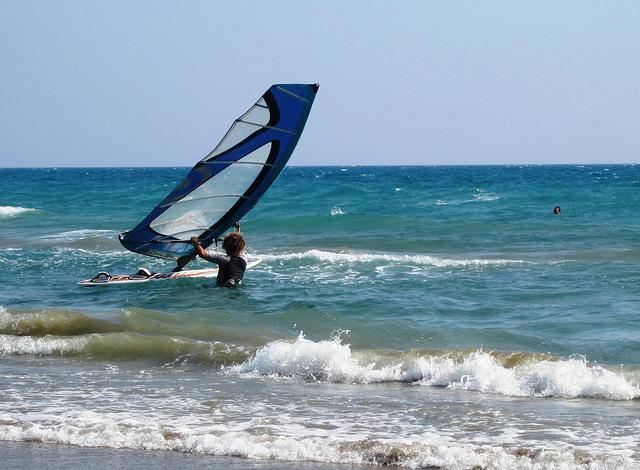What is he doing? windsurfing 